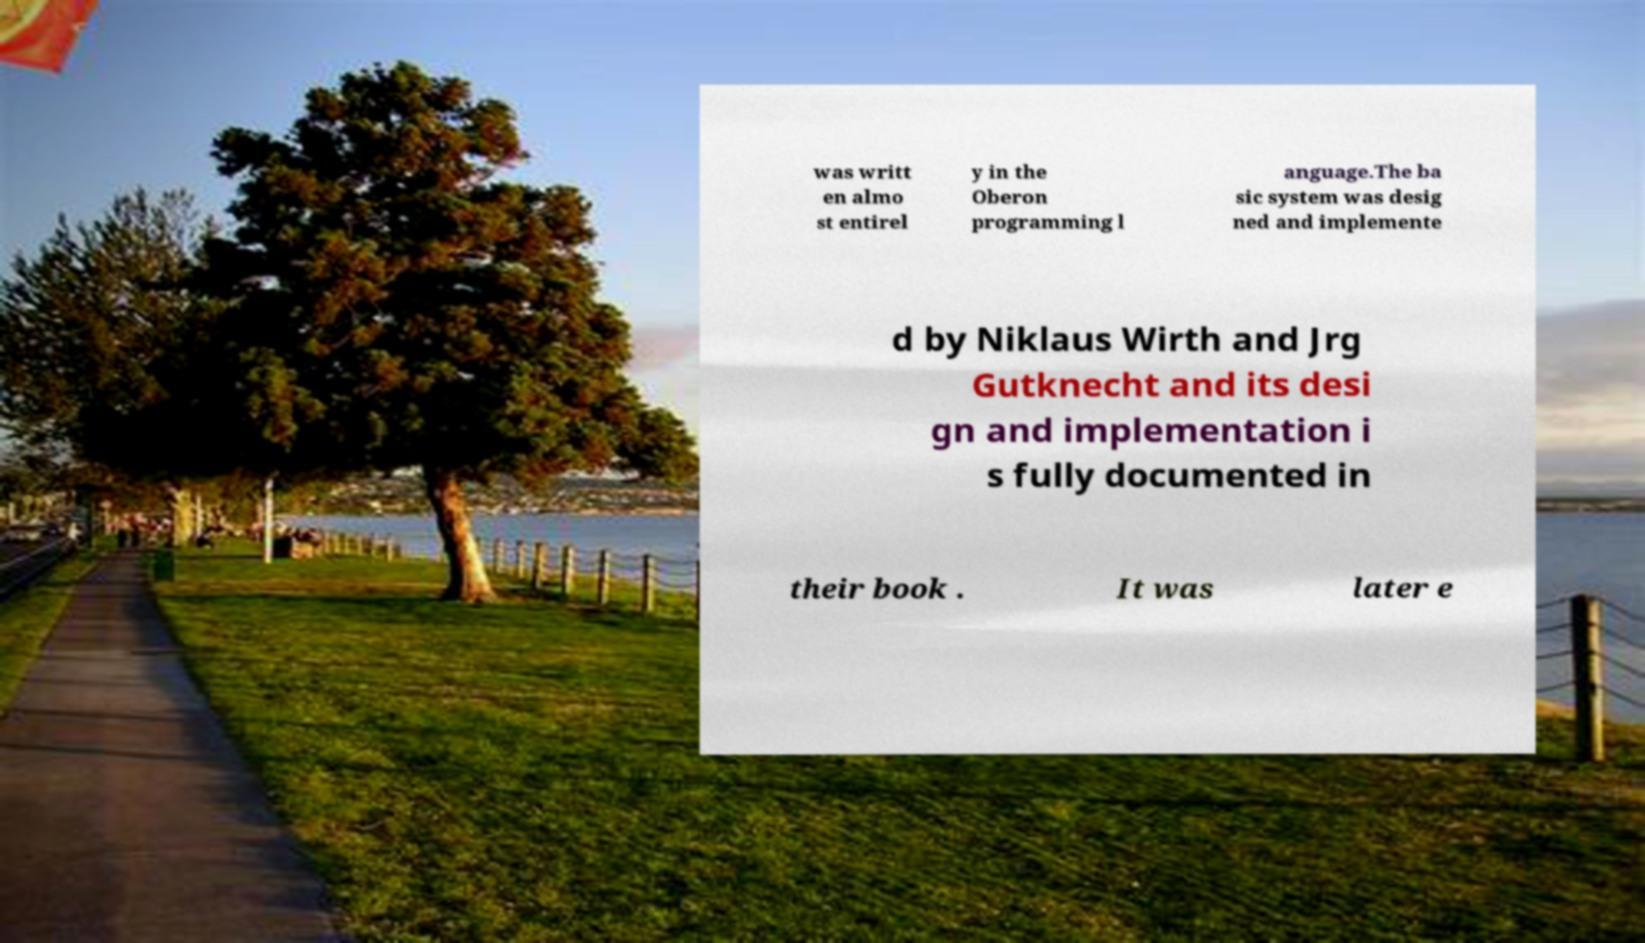Please read and relay the text visible in this image. What does it say? was writt en almo st entirel y in the Oberon programming l anguage.The ba sic system was desig ned and implemente d by Niklaus Wirth and Jrg Gutknecht and its desi gn and implementation i s fully documented in their book . It was later e 